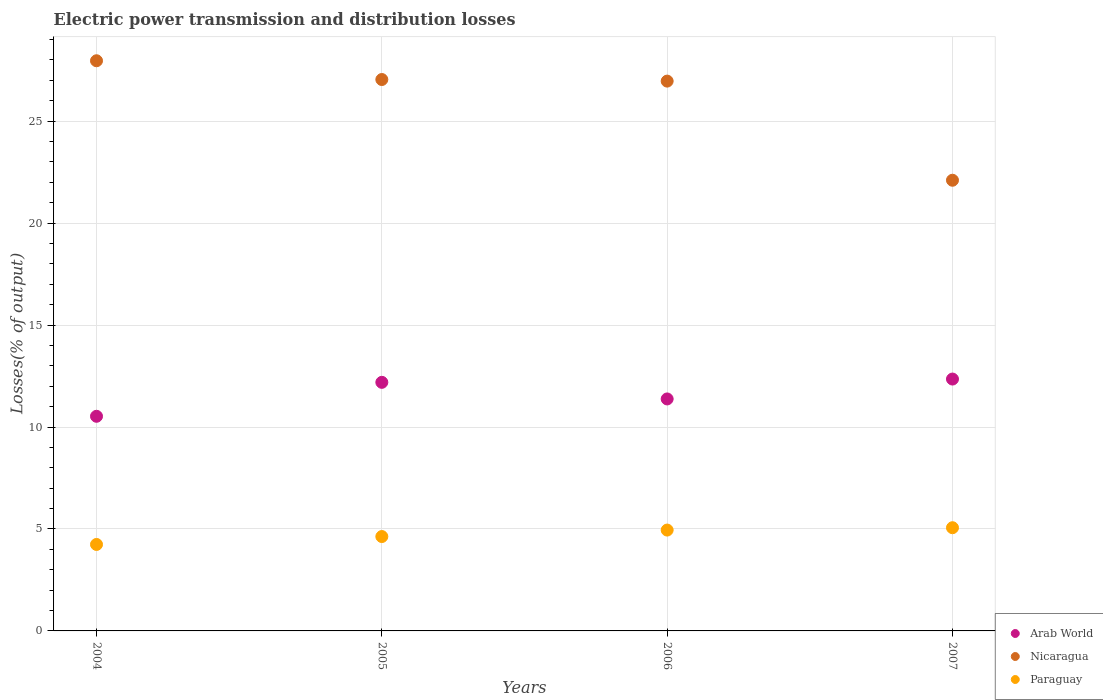How many different coloured dotlines are there?
Your answer should be compact. 3. What is the electric power transmission and distribution losses in Paraguay in 2004?
Offer a very short reply. 4.24. Across all years, what is the maximum electric power transmission and distribution losses in Paraguay?
Your answer should be compact. 5.06. Across all years, what is the minimum electric power transmission and distribution losses in Paraguay?
Offer a very short reply. 4.24. In which year was the electric power transmission and distribution losses in Arab World maximum?
Keep it short and to the point. 2007. What is the total electric power transmission and distribution losses in Arab World in the graph?
Your response must be concise. 46.44. What is the difference between the electric power transmission and distribution losses in Arab World in 2006 and that in 2007?
Your answer should be very brief. -0.98. What is the difference between the electric power transmission and distribution losses in Nicaragua in 2006 and the electric power transmission and distribution losses in Paraguay in 2005?
Provide a succinct answer. 22.33. What is the average electric power transmission and distribution losses in Paraguay per year?
Make the answer very short. 4.72. In the year 2006, what is the difference between the electric power transmission and distribution losses in Nicaragua and electric power transmission and distribution losses in Paraguay?
Keep it short and to the point. 22.02. What is the ratio of the electric power transmission and distribution losses in Nicaragua in 2004 to that in 2007?
Make the answer very short. 1.27. Is the electric power transmission and distribution losses in Paraguay in 2006 less than that in 2007?
Provide a succinct answer. Yes. What is the difference between the highest and the second highest electric power transmission and distribution losses in Arab World?
Your response must be concise. 0.16. What is the difference between the highest and the lowest electric power transmission and distribution losses in Paraguay?
Your response must be concise. 0.82. Is the sum of the electric power transmission and distribution losses in Nicaragua in 2005 and 2006 greater than the maximum electric power transmission and distribution losses in Arab World across all years?
Make the answer very short. Yes. Is the electric power transmission and distribution losses in Paraguay strictly less than the electric power transmission and distribution losses in Nicaragua over the years?
Offer a terse response. Yes. What is the difference between two consecutive major ticks on the Y-axis?
Ensure brevity in your answer.  5. Are the values on the major ticks of Y-axis written in scientific E-notation?
Your response must be concise. No. How many legend labels are there?
Give a very brief answer. 3. What is the title of the graph?
Ensure brevity in your answer.  Electric power transmission and distribution losses. What is the label or title of the Y-axis?
Offer a terse response. Losses(% of output). What is the Losses(% of output) of Arab World in 2004?
Keep it short and to the point. 10.53. What is the Losses(% of output) in Nicaragua in 2004?
Keep it short and to the point. 27.96. What is the Losses(% of output) in Paraguay in 2004?
Give a very brief answer. 4.24. What is the Losses(% of output) of Arab World in 2005?
Offer a very short reply. 12.19. What is the Losses(% of output) in Nicaragua in 2005?
Offer a terse response. 27.04. What is the Losses(% of output) of Paraguay in 2005?
Your answer should be compact. 4.63. What is the Losses(% of output) in Arab World in 2006?
Offer a terse response. 11.38. What is the Losses(% of output) of Nicaragua in 2006?
Your response must be concise. 26.96. What is the Losses(% of output) in Paraguay in 2006?
Offer a very short reply. 4.95. What is the Losses(% of output) of Arab World in 2007?
Offer a terse response. 12.35. What is the Losses(% of output) in Nicaragua in 2007?
Keep it short and to the point. 22.1. What is the Losses(% of output) in Paraguay in 2007?
Your response must be concise. 5.06. Across all years, what is the maximum Losses(% of output) of Arab World?
Provide a succinct answer. 12.35. Across all years, what is the maximum Losses(% of output) of Nicaragua?
Provide a succinct answer. 27.96. Across all years, what is the maximum Losses(% of output) of Paraguay?
Your answer should be compact. 5.06. Across all years, what is the minimum Losses(% of output) in Arab World?
Keep it short and to the point. 10.53. Across all years, what is the minimum Losses(% of output) of Nicaragua?
Provide a short and direct response. 22.1. Across all years, what is the minimum Losses(% of output) of Paraguay?
Provide a succinct answer. 4.24. What is the total Losses(% of output) of Arab World in the graph?
Provide a succinct answer. 46.44. What is the total Losses(% of output) in Nicaragua in the graph?
Provide a short and direct response. 104.06. What is the total Losses(% of output) in Paraguay in the graph?
Provide a short and direct response. 18.88. What is the difference between the Losses(% of output) of Arab World in 2004 and that in 2005?
Your answer should be compact. -1.66. What is the difference between the Losses(% of output) in Nicaragua in 2004 and that in 2005?
Keep it short and to the point. 0.92. What is the difference between the Losses(% of output) of Paraguay in 2004 and that in 2005?
Give a very brief answer. -0.39. What is the difference between the Losses(% of output) in Arab World in 2004 and that in 2006?
Ensure brevity in your answer.  -0.85. What is the difference between the Losses(% of output) in Paraguay in 2004 and that in 2006?
Offer a terse response. -0.71. What is the difference between the Losses(% of output) in Arab World in 2004 and that in 2007?
Make the answer very short. -1.83. What is the difference between the Losses(% of output) in Nicaragua in 2004 and that in 2007?
Give a very brief answer. 5.86. What is the difference between the Losses(% of output) of Paraguay in 2004 and that in 2007?
Make the answer very short. -0.82. What is the difference between the Losses(% of output) of Arab World in 2005 and that in 2006?
Provide a succinct answer. 0.81. What is the difference between the Losses(% of output) of Nicaragua in 2005 and that in 2006?
Your answer should be compact. 0.08. What is the difference between the Losses(% of output) in Paraguay in 2005 and that in 2006?
Ensure brevity in your answer.  -0.32. What is the difference between the Losses(% of output) in Arab World in 2005 and that in 2007?
Make the answer very short. -0.16. What is the difference between the Losses(% of output) of Nicaragua in 2005 and that in 2007?
Provide a succinct answer. 4.94. What is the difference between the Losses(% of output) of Paraguay in 2005 and that in 2007?
Offer a terse response. -0.43. What is the difference between the Losses(% of output) in Arab World in 2006 and that in 2007?
Offer a very short reply. -0.98. What is the difference between the Losses(% of output) in Nicaragua in 2006 and that in 2007?
Offer a terse response. 4.86. What is the difference between the Losses(% of output) in Paraguay in 2006 and that in 2007?
Make the answer very short. -0.12. What is the difference between the Losses(% of output) of Arab World in 2004 and the Losses(% of output) of Nicaragua in 2005?
Offer a terse response. -16.51. What is the difference between the Losses(% of output) in Arab World in 2004 and the Losses(% of output) in Paraguay in 2005?
Your response must be concise. 5.9. What is the difference between the Losses(% of output) in Nicaragua in 2004 and the Losses(% of output) in Paraguay in 2005?
Provide a succinct answer. 23.33. What is the difference between the Losses(% of output) in Arab World in 2004 and the Losses(% of output) in Nicaragua in 2006?
Give a very brief answer. -16.44. What is the difference between the Losses(% of output) of Arab World in 2004 and the Losses(% of output) of Paraguay in 2006?
Make the answer very short. 5.58. What is the difference between the Losses(% of output) of Nicaragua in 2004 and the Losses(% of output) of Paraguay in 2006?
Provide a short and direct response. 23.01. What is the difference between the Losses(% of output) of Arab World in 2004 and the Losses(% of output) of Nicaragua in 2007?
Ensure brevity in your answer.  -11.58. What is the difference between the Losses(% of output) of Arab World in 2004 and the Losses(% of output) of Paraguay in 2007?
Make the answer very short. 5.46. What is the difference between the Losses(% of output) of Nicaragua in 2004 and the Losses(% of output) of Paraguay in 2007?
Make the answer very short. 22.9. What is the difference between the Losses(% of output) of Arab World in 2005 and the Losses(% of output) of Nicaragua in 2006?
Provide a succinct answer. -14.77. What is the difference between the Losses(% of output) in Arab World in 2005 and the Losses(% of output) in Paraguay in 2006?
Give a very brief answer. 7.24. What is the difference between the Losses(% of output) of Nicaragua in 2005 and the Losses(% of output) of Paraguay in 2006?
Provide a succinct answer. 22.09. What is the difference between the Losses(% of output) of Arab World in 2005 and the Losses(% of output) of Nicaragua in 2007?
Provide a short and direct response. -9.91. What is the difference between the Losses(% of output) in Arab World in 2005 and the Losses(% of output) in Paraguay in 2007?
Offer a very short reply. 7.13. What is the difference between the Losses(% of output) of Nicaragua in 2005 and the Losses(% of output) of Paraguay in 2007?
Make the answer very short. 21.98. What is the difference between the Losses(% of output) of Arab World in 2006 and the Losses(% of output) of Nicaragua in 2007?
Offer a very short reply. -10.72. What is the difference between the Losses(% of output) in Arab World in 2006 and the Losses(% of output) in Paraguay in 2007?
Keep it short and to the point. 6.32. What is the difference between the Losses(% of output) in Nicaragua in 2006 and the Losses(% of output) in Paraguay in 2007?
Your response must be concise. 21.9. What is the average Losses(% of output) of Arab World per year?
Your answer should be very brief. 11.61. What is the average Losses(% of output) in Nicaragua per year?
Offer a very short reply. 26.02. What is the average Losses(% of output) in Paraguay per year?
Ensure brevity in your answer.  4.72. In the year 2004, what is the difference between the Losses(% of output) in Arab World and Losses(% of output) in Nicaragua?
Give a very brief answer. -17.43. In the year 2004, what is the difference between the Losses(% of output) in Arab World and Losses(% of output) in Paraguay?
Give a very brief answer. 6.29. In the year 2004, what is the difference between the Losses(% of output) in Nicaragua and Losses(% of output) in Paraguay?
Offer a very short reply. 23.72. In the year 2005, what is the difference between the Losses(% of output) of Arab World and Losses(% of output) of Nicaragua?
Give a very brief answer. -14.85. In the year 2005, what is the difference between the Losses(% of output) in Arab World and Losses(% of output) in Paraguay?
Your answer should be compact. 7.56. In the year 2005, what is the difference between the Losses(% of output) in Nicaragua and Losses(% of output) in Paraguay?
Your answer should be compact. 22.41. In the year 2006, what is the difference between the Losses(% of output) of Arab World and Losses(% of output) of Nicaragua?
Provide a short and direct response. -15.59. In the year 2006, what is the difference between the Losses(% of output) of Arab World and Losses(% of output) of Paraguay?
Make the answer very short. 6.43. In the year 2006, what is the difference between the Losses(% of output) in Nicaragua and Losses(% of output) in Paraguay?
Your answer should be compact. 22.02. In the year 2007, what is the difference between the Losses(% of output) of Arab World and Losses(% of output) of Nicaragua?
Your answer should be compact. -9.75. In the year 2007, what is the difference between the Losses(% of output) of Arab World and Losses(% of output) of Paraguay?
Provide a succinct answer. 7.29. In the year 2007, what is the difference between the Losses(% of output) of Nicaragua and Losses(% of output) of Paraguay?
Provide a succinct answer. 17.04. What is the ratio of the Losses(% of output) of Arab World in 2004 to that in 2005?
Keep it short and to the point. 0.86. What is the ratio of the Losses(% of output) in Nicaragua in 2004 to that in 2005?
Provide a succinct answer. 1.03. What is the ratio of the Losses(% of output) in Paraguay in 2004 to that in 2005?
Provide a succinct answer. 0.92. What is the ratio of the Losses(% of output) in Arab World in 2004 to that in 2006?
Ensure brevity in your answer.  0.93. What is the ratio of the Losses(% of output) in Nicaragua in 2004 to that in 2006?
Ensure brevity in your answer.  1.04. What is the ratio of the Losses(% of output) in Paraguay in 2004 to that in 2006?
Keep it short and to the point. 0.86. What is the ratio of the Losses(% of output) in Arab World in 2004 to that in 2007?
Give a very brief answer. 0.85. What is the ratio of the Losses(% of output) of Nicaragua in 2004 to that in 2007?
Keep it short and to the point. 1.27. What is the ratio of the Losses(% of output) in Paraguay in 2004 to that in 2007?
Your response must be concise. 0.84. What is the ratio of the Losses(% of output) of Arab World in 2005 to that in 2006?
Offer a very short reply. 1.07. What is the ratio of the Losses(% of output) of Paraguay in 2005 to that in 2006?
Your response must be concise. 0.94. What is the ratio of the Losses(% of output) in Nicaragua in 2005 to that in 2007?
Provide a succinct answer. 1.22. What is the ratio of the Losses(% of output) in Paraguay in 2005 to that in 2007?
Offer a terse response. 0.91. What is the ratio of the Losses(% of output) in Arab World in 2006 to that in 2007?
Your answer should be very brief. 0.92. What is the ratio of the Losses(% of output) in Nicaragua in 2006 to that in 2007?
Ensure brevity in your answer.  1.22. What is the ratio of the Losses(% of output) in Paraguay in 2006 to that in 2007?
Ensure brevity in your answer.  0.98. What is the difference between the highest and the second highest Losses(% of output) in Arab World?
Make the answer very short. 0.16. What is the difference between the highest and the second highest Losses(% of output) in Paraguay?
Your answer should be very brief. 0.12. What is the difference between the highest and the lowest Losses(% of output) in Arab World?
Your response must be concise. 1.83. What is the difference between the highest and the lowest Losses(% of output) of Nicaragua?
Make the answer very short. 5.86. What is the difference between the highest and the lowest Losses(% of output) of Paraguay?
Provide a short and direct response. 0.82. 